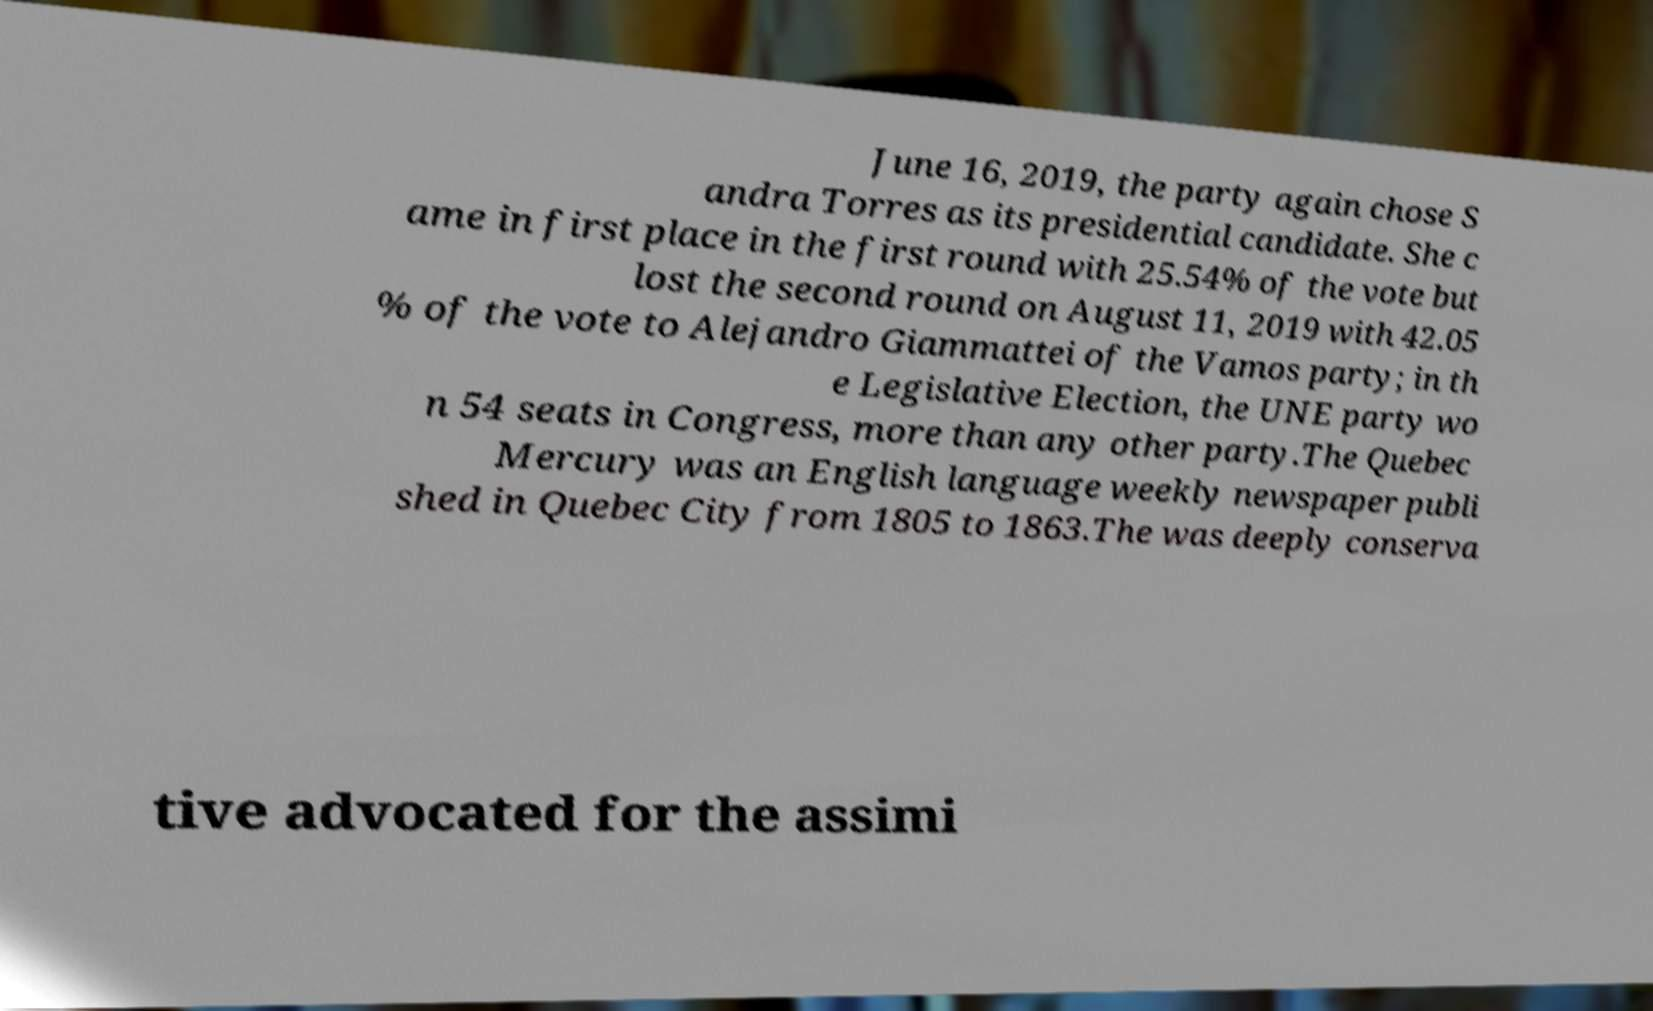Please identify and transcribe the text found in this image. June 16, 2019, the party again chose S andra Torres as its presidential candidate. She c ame in first place in the first round with 25.54% of the vote but lost the second round on August 11, 2019 with 42.05 % of the vote to Alejandro Giammattei of the Vamos party; in th e Legislative Election, the UNE party wo n 54 seats in Congress, more than any other party.The Quebec Mercury was an English language weekly newspaper publi shed in Quebec City from 1805 to 1863.The was deeply conserva tive advocated for the assimi 